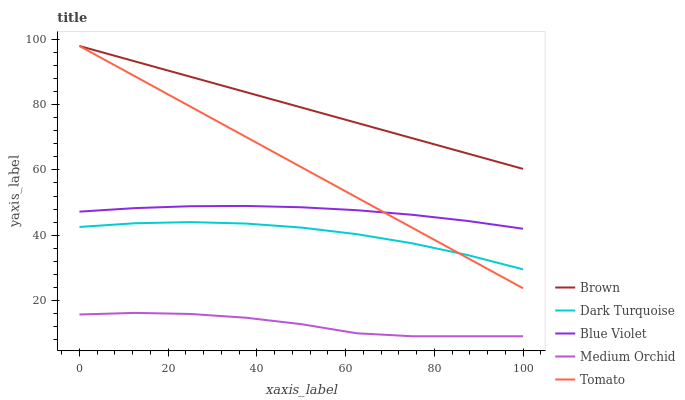Does Medium Orchid have the minimum area under the curve?
Answer yes or no. Yes. Does Brown have the maximum area under the curve?
Answer yes or no. Yes. Does Brown have the minimum area under the curve?
Answer yes or no. No. Does Medium Orchid have the maximum area under the curve?
Answer yes or no. No. Is Tomato the smoothest?
Answer yes or no. Yes. Is Medium Orchid the roughest?
Answer yes or no. Yes. Is Brown the smoothest?
Answer yes or no. No. Is Brown the roughest?
Answer yes or no. No. Does Medium Orchid have the lowest value?
Answer yes or no. Yes. Does Brown have the lowest value?
Answer yes or no. No. Does Brown have the highest value?
Answer yes or no. Yes. Does Medium Orchid have the highest value?
Answer yes or no. No. Is Medium Orchid less than Dark Turquoise?
Answer yes or no. Yes. Is Brown greater than Blue Violet?
Answer yes or no. Yes. Does Tomato intersect Dark Turquoise?
Answer yes or no. Yes. Is Tomato less than Dark Turquoise?
Answer yes or no. No. Is Tomato greater than Dark Turquoise?
Answer yes or no. No. Does Medium Orchid intersect Dark Turquoise?
Answer yes or no. No. 